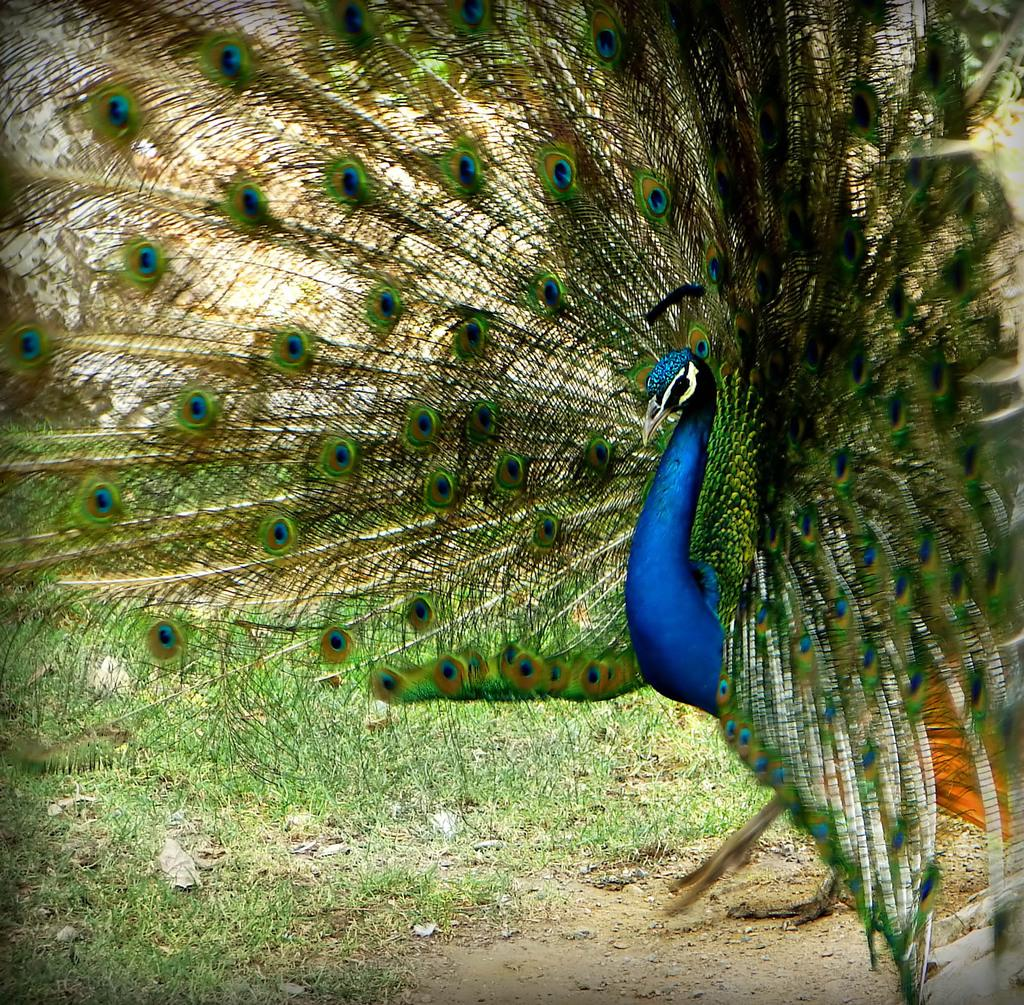What animal can be seen in the image? There is a peacock in the image. What is the peacock doing in the image? The peacock is walking on the ground in the image. What type of terrain is visible in the background of the image? There is grass visible in the background of the image. What type of marble is used to build the corn silo in the image? There is no corn silo or marble present in the image; it features a peacock walking on the ground with grass in the background. 